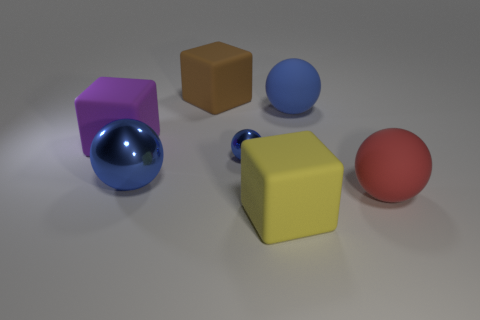Do the matte object left of the big brown matte object and the big metal object have the same color?
Ensure brevity in your answer.  No. Are there any matte blocks of the same color as the tiny metallic ball?
Give a very brief answer. No. There is a big purple cube; how many large matte things are in front of it?
Provide a succinct answer. 2. How many other things are the same size as the blue matte object?
Provide a short and direct response. 5. Is the material of the blue object that is behind the small ball the same as the big blue object that is to the left of the brown object?
Give a very brief answer. No. There is a metallic ball that is the same size as the brown cube; what is its color?
Give a very brief answer. Blue. Is there any other thing that has the same color as the tiny metallic object?
Make the answer very short. Yes. What is the size of the shiny object on the right side of the big blue sphere in front of the big matte object to the left of the brown block?
Offer a terse response. Small. There is a large sphere that is to the right of the large shiny object and in front of the large purple block; what color is it?
Keep it short and to the point. Red. There is a matte cube that is in front of the large red matte ball; what is its size?
Your response must be concise. Large. 